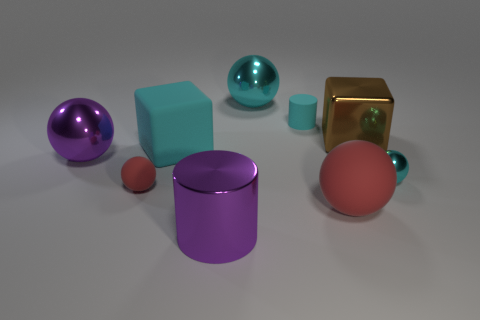How many purple objects are on the right side of the purple metallic object on the left side of the tiny matte ball that is behind the large purple metallic cylinder?
Make the answer very short. 1. What number of other red objects are the same shape as the big red rubber thing?
Keep it short and to the point. 1. Do the large shiny cylinder that is to the left of the cyan cylinder and the large matte ball have the same color?
Keep it short and to the point. No. There is a matte object left of the cyan matte thing on the left side of the cyan shiny thing that is behind the tiny cyan metallic sphere; what shape is it?
Provide a short and direct response. Sphere. Do the brown object and the purple metal thing to the right of the big purple sphere have the same size?
Offer a terse response. Yes. Are there any brown matte things that have the same size as the purple cylinder?
Your response must be concise. No. How many other things are made of the same material as the big red ball?
Keep it short and to the point. 3. What is the color of the object that is both behind the large matte cube and right of the tiny cylinder?
Provide a short and direct response. Brown. Do the cylinder in front of the tiny cyan rubber cylinder and the cube on the left side of the large red sphere have the same material?
Provide a succinct answer. No. There is a shiny sphere right of the brown cube; does it have the same size as the big purple cylinder?
Offer a terse response. No. 